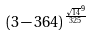Convert formula to latex. <formula><loc_0><loc_0><loc_500><loc_500>( 3 - 3 6 4 ) ^ { \frac { \sqrt { 1 4 } ^ { 9 } } { 3 2 5 } }</formula> 